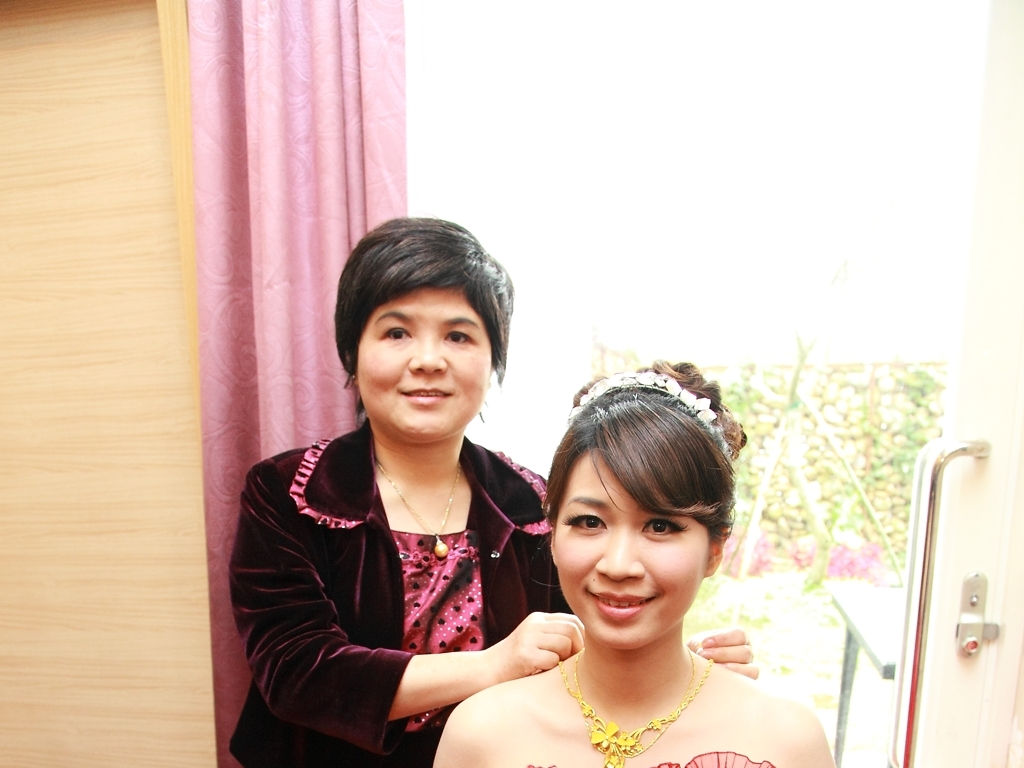Is the photo properly exposed? The photo is somewhat overexposed. The light coming from the window behind the subjects has caused the camera to capture a brighter scene than ideal, resulting in a loss of detail in the brighter areas of the image. Adjusting the exposure could balance the light and shadow for a more evenly lit photograph. 